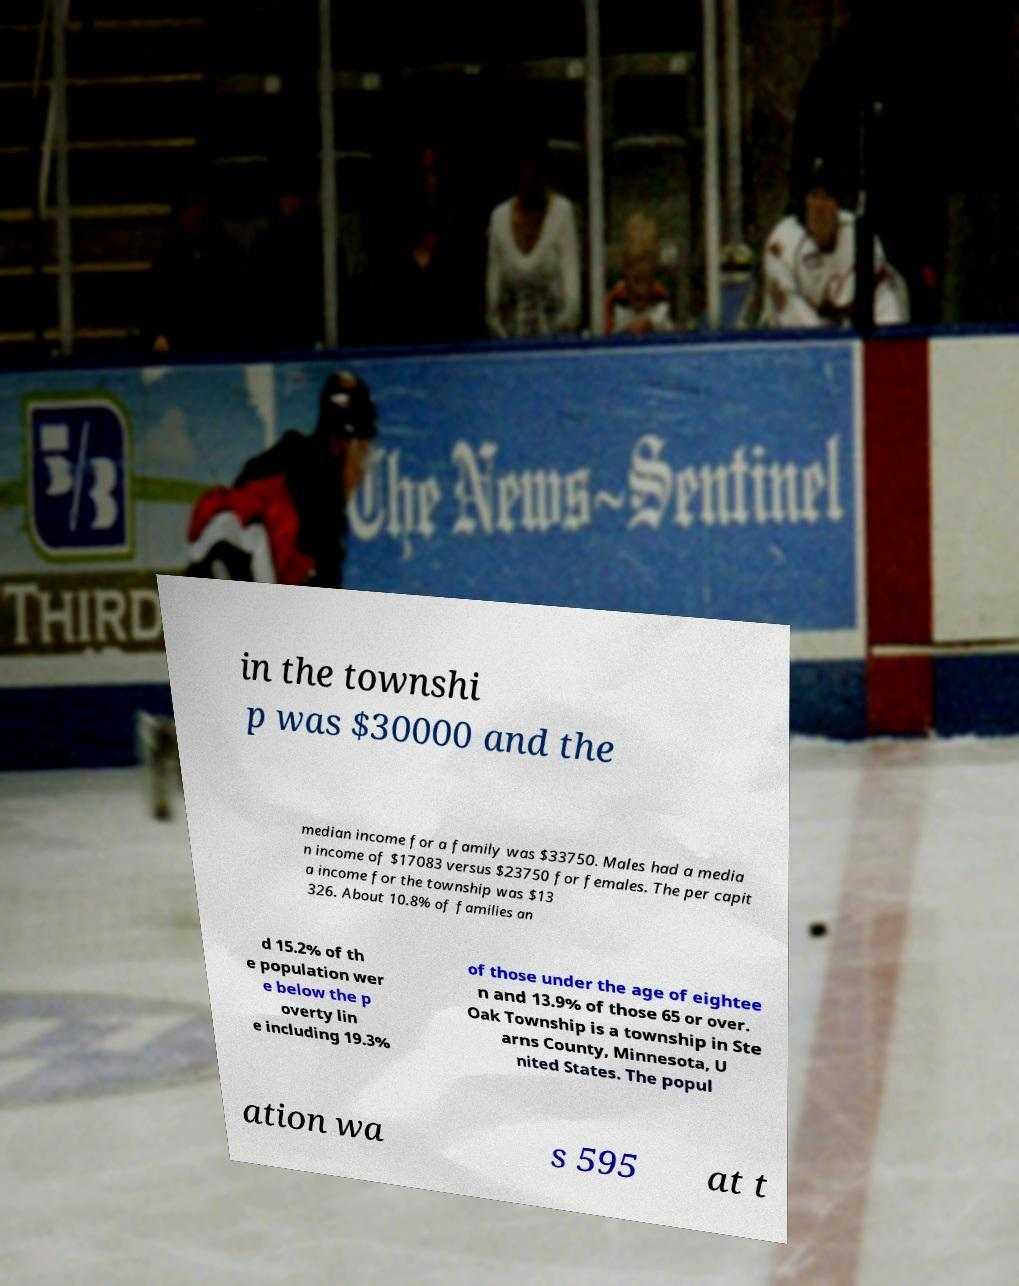Please read and relay the text visible in this image. What does it say? in the townshi p was $30000 and the median income for a family was $33750. Males had a media n income of $17083 versus $23750 for females. The per capit a income for the township was $13 326. About 10.8% of families an d 15.2% of th e population wer e below the p overty lin e including 19.3% of those under the age of eightee n and 13.9% of those 65 or over. Oak Township is a township in Ste arns County, Minnesota, U nited States. The popul ation wa s 595 at t 